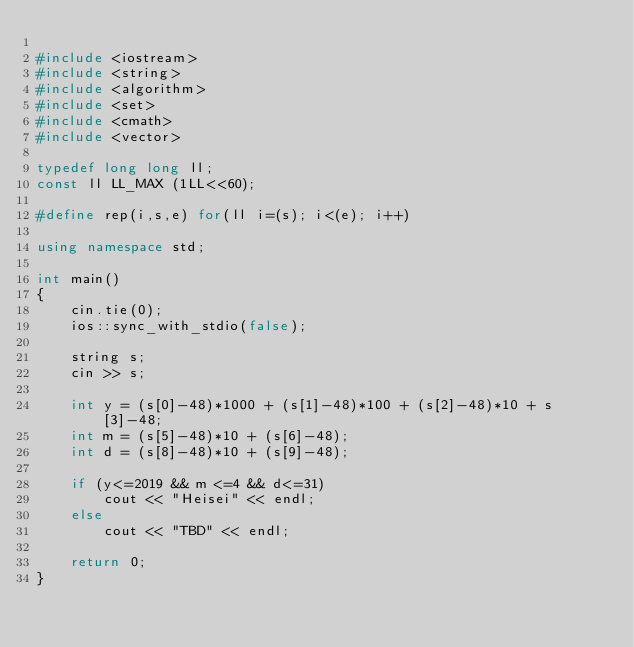<code> <loc_0><loc_0><loc_500><loc_500><_C++_>
#include <iostream>
#include <string>
#include <algorithm>
#include <set>
#include <cmath>
#include <vector>

typedef long long ll;
const ll LL_MAX (1LL<<60);

#define rep(i,s,e) for(ll i=(s); i<(e); i++) 

using namespace std;

int main()
{
    cin.tie(0);
    ios::sync_with_stdio(false);

    string s;
    cin >> s;

    int y = (s[0]-48)*1000 + (s[1]-48)*100 + (s[2]-48)*10 + s[3]-48;
    int m = (s[5]-48)*10 + (s[6]-48);
    int d = (s[8]-48)*10 + (s[9]-48);

    if (y<=2019 && m <=4 && d<=31)
        cout << "Heisei" << endl;
    else
        cout << "TBD" << endl;

    return 0;
}
</code> 